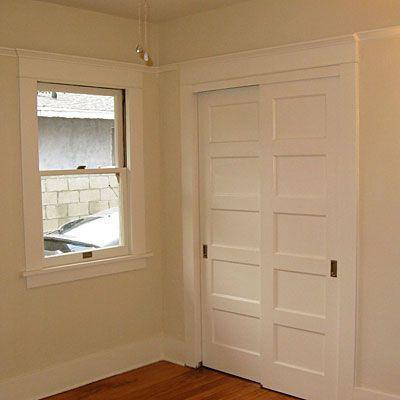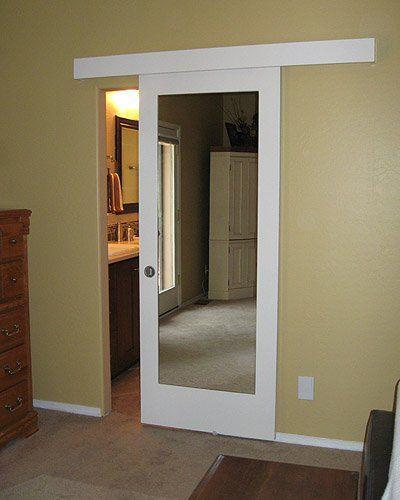The first image is the image on the left, the second image is the image on the right. For the images displayed, is the sentence "There are three doors." factually correct? Answer yes or no. Yes. The first image is the image on the left, the second image is the image on the right. Analyze the images presented: Is the assertion "A door is mirrored." valid? Answer yes or no. Yes. 